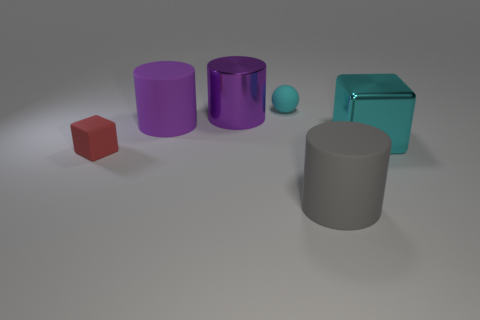Subtract all big purple rubber cylinders. How many cylinders are left? 2 Subtract 1 cylinders. How many cylinders are left? 2 Subtract all cyan cubes. How many cubes are left? 1 Add 3 big gray rubber cylinders. How many objects exist? 9 Subtract all blue blocks. How many purple spheres are left? 0 Subtract all balls. How many objects are left? 5 Subtract all green cubes. Subtract all purple spheres. How many cubes are left? 2 Subtract all large cyan things. Subtract all cyan metal blocks. How many objects are left? 4 Add 2 spheres. How many spheres are left? 3 Add 4 cyan metallic objects. How many cyan metallic objects exist? 5 